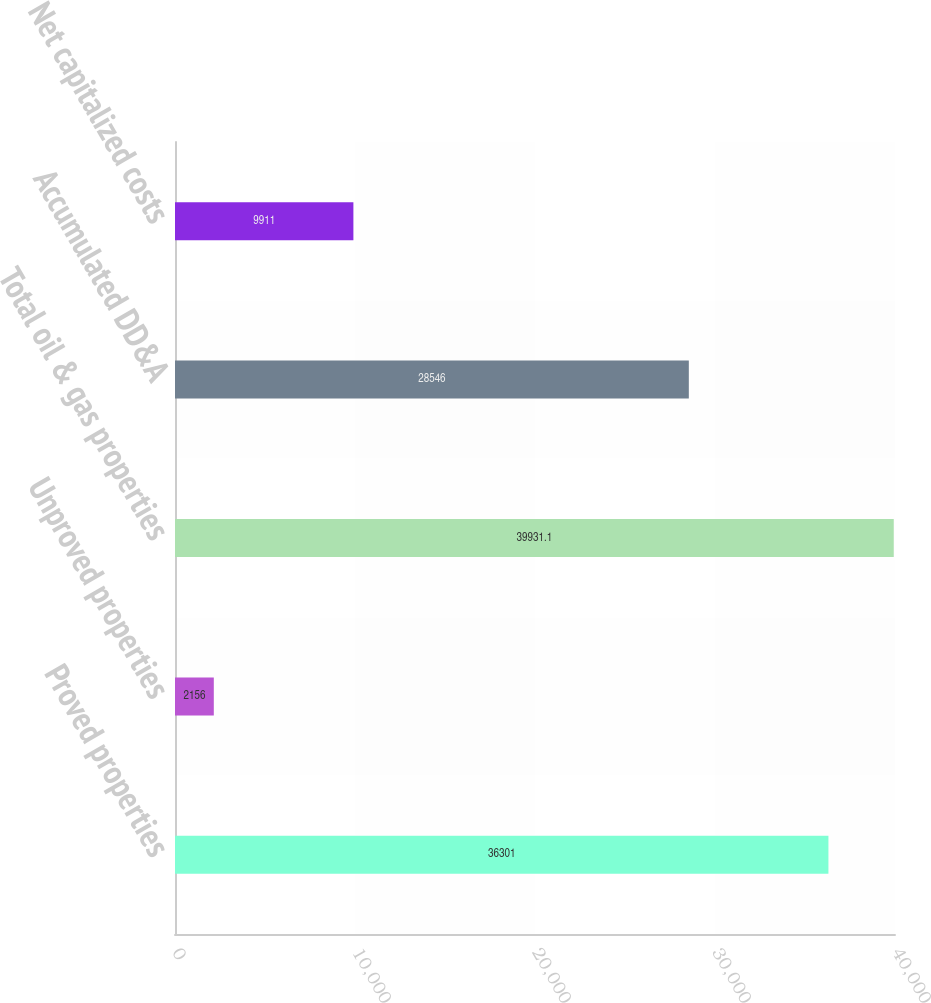<chart> <loc_0><loc_0><loc_500><loc_500><bar_chart><fcel>Proved properties<fcel>Unproved properties<fcel>Total oil & gas properties<fcel>Accumulated DD&A<fcel>Net capitalized costs<nl><fcel>36301<fcel>2156<fcel>39931.1<fcel>28546<fcel>9911<nl></chart> 